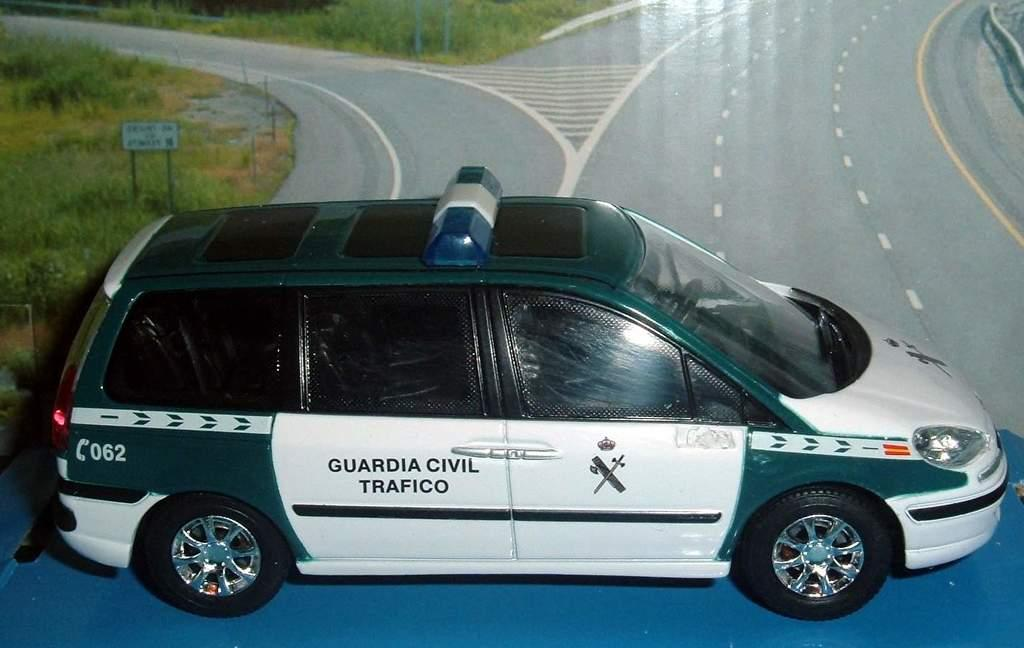<image>
Give a short and clear explanation of the subsequent image. a guardia civil trafico van on the road 